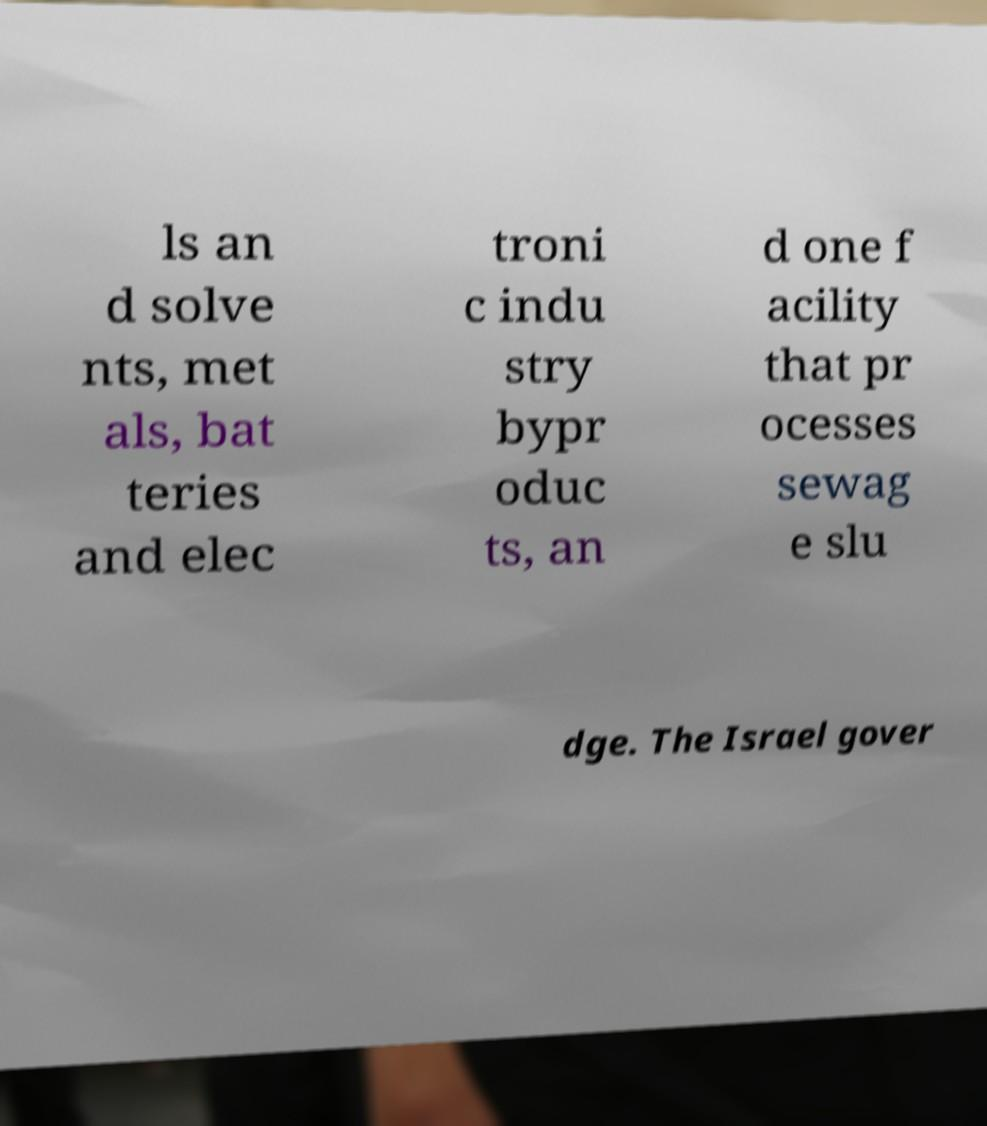Could you extract and type out the text from this image? ls an d solve nts, met als, bat teries and elec troni c indu stry bypr oduc ts, an d one f acility that pr ocesses sewag e slu dge. The Israel gover 